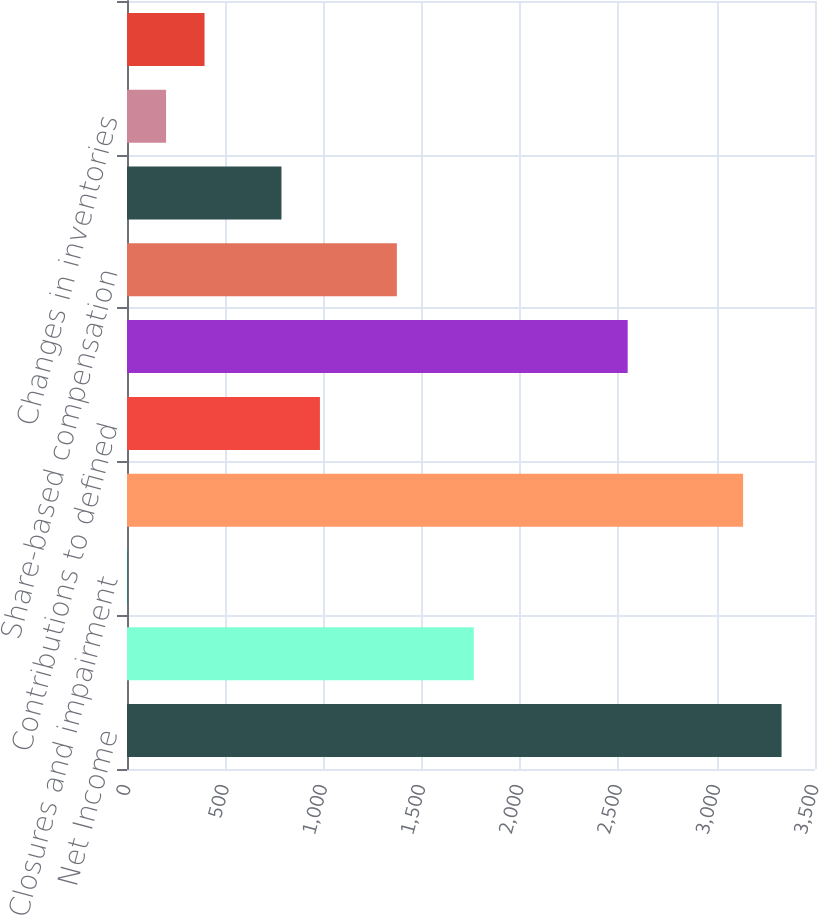Convert chart. <chart><loc_0><loc_0><loc_500><loc_500><bar_chart><fcel>Net Income<fcel>Depreciation and amortization<fcel>Closures and impairment<fcel>Refranchising (gain) loss<fcel>Contributions to defined<fcel>Deferred income taxes<fcel>Share-based compensation<fcel>Changes in accounts and notes<fcel>Changes in inventories<fcel>Changes in prepaid expenses<nl><fcel>3329.9<fcel>1764.3<fcel>3<fcel>3134.2<fcel>981.5<fcel>2547.1<fcel>1372.9<fcel>785.8<fcel>198.7<fcel>394.4<nl></chart> 